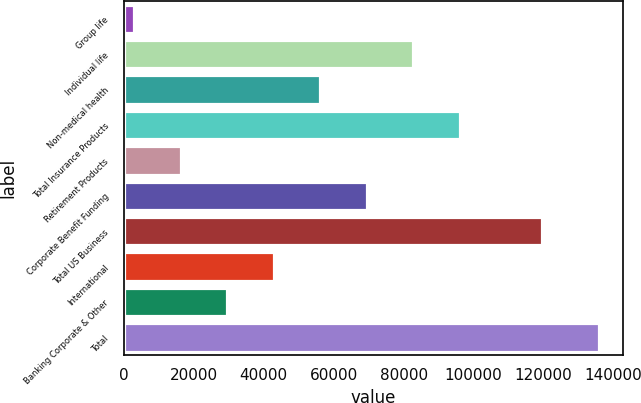<chart> <loc_0><loc_0><loc_500><loc_500><bar_chart><fcel>Group life<fcel>Individual life<fcel>Non-medical health<fcel>Total Insurance Products<fcel>Retirement Products<fcel>Corporate Benefit Funding<fcel>Total US Business<fcel>International<fcel>Banking Corporate & Other<fcel>Total<nl><fcel>2981<fcel>82719.8<fcel>56140.2<fcel>96009.6<fcel>16270.8<fcel>69430<fcel>119585<fcel>42850.4<fcel>29560.6<fcel>135879<nl></chart> 